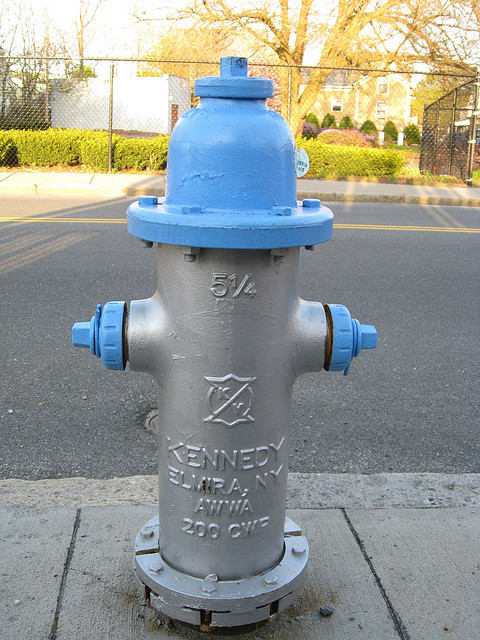Please extract the text content from this image. 5 1/4 k v KENNEDY elmira NY awwa 200 CWP 